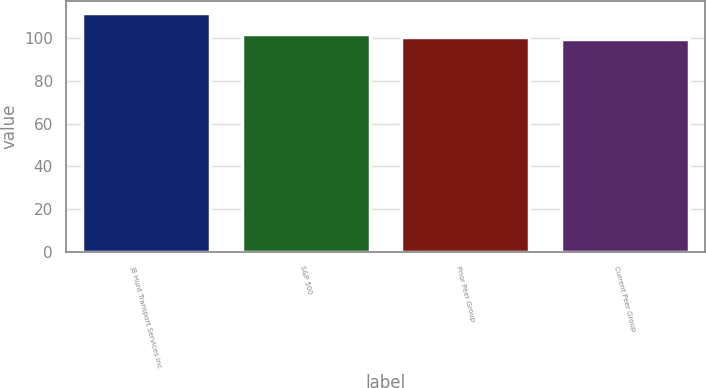Convert chart to OTSL. <chart><loc_0><loc_0><loc_500><loc_500><bar_chart><fcel>JB Hunt Transport Services Inc<fcel>S&P 500<fcel>Prior Peer Group<fcel>Current Peer Group<nl><fcel>111.74<fcel>102.11<fcel>100.73<fcel>99.51<nl></chart> 